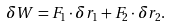<formula> <loc_0><loc_0><loc_500><loc_500>\delta W = F _ { 1 } \cdot \delta r _ { 1 } + F _ { 2 } \cdot \delta r _ { 2 } .</formula> 